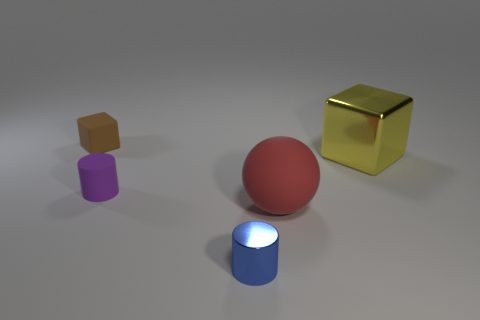Add 1 yellow shiny objects. How many objects exist? 6 Subtract all cylinders. How many objects are left? 3 Add 2 big metal cubes. How many big metal cubes exist? 3 Subtract 0 purple cubes. How many objects are left? 5 Subtract all big shiny objects. Subtract all tiny blocks. How many objects are left? 3 Add 4 rubber cylinders. How many rubber cylinders are left? 5 